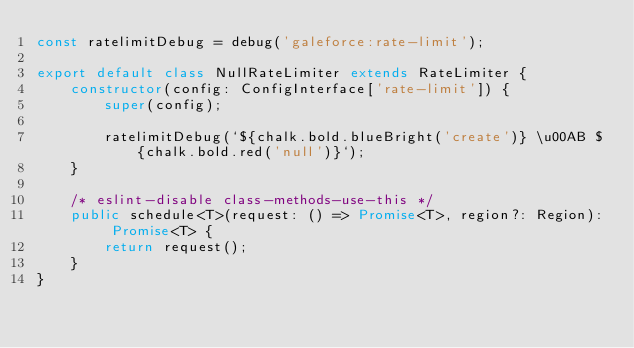<code> <loc_0><loc_0><loc_500><loc_500><_TypeScript_>const ratelimitDebug = debug('galeforce:rate-limit');

export default class NullRateLimiter extends RateLimiter {
    constructor(config: ConfigInterface['rate-limit']) {
        super(config);

        ratelimitDebug(`${chalk.bold.blueBright('create')} \u00AB ${chalk.bold.red('null')}`);
    }

    /* eslint-disable class-methods-use-this */
    public schedule<T>(request: () => Promise<T>, region?: Region): Promise<T> {
        return request();
    }
}
</code> 